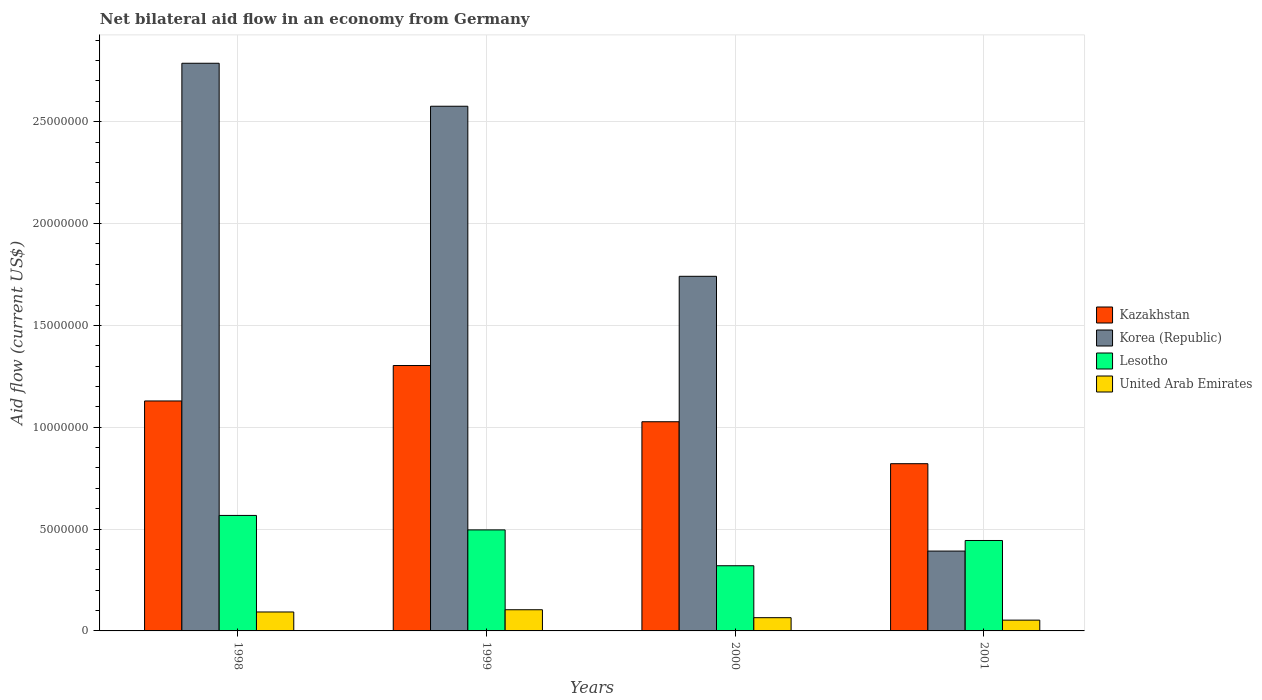How many different coloured bars are there?
Your response must be concise. 4. Are the number of bars per tick equal to the number of legend labels?
Offer a very short reply. Yes. How many bars are there on the 1st tick from the left?
Make the answer very short. 4. How many bars are there on the 1st tick from the right?
Give a very brief answer. 4. What is the label of the 3rd group of bars from the left?
Give a very brief answer. 2000. What is the net bilateral aid flow in Kazakhstan in 2000?
Offer a very short reply. 1.03e+07. Across all years, what is the maximum net bilateral aid flow in Kazakhstan?
Your response must be concise. 1.30e+07. Across all years, what is the minimum net bilateral aid flow in Lesotho?
Your answer should be compact. 3.20e+06. What is the total net bilateral aid flow in Kazakhstan in the graph?
Your response must be concise. 4.28e+07. What is the difference between the net bilateral aid flow in United Arab Emirates in 1998 and that in 1999?
Your answer should be compact. -1.10e+05. What is the difference between the net bilateral aid flow in United Arab Emirates in 1998 and the net bilateral aid flow in Korea (Republic) in 2001?
Give a very brief answer. -2.99e+06. What is the average net bilateral aid flow in United Arab Emirates per year?
Your answer should be compact. 7.88e+05. In the year 2000, what is the difference between the net bilateral aid flow in Lesotho and net bilateral aid flow in United Arab Emirates?
Make the answer very short. 2.55e+06. What is the ratio of the net bilateral aid flow in Korea (Republic) in 1998 to that in 2000?
Ensure brevity in your answer.  1.6. Is the net bilateral aid flow in United Arab Emirates in 2000 less than that in 2001?
Give a very brief answer. No. What is the difference between the highest and the second highest net bilateral aid flow in Lesotho?
Your response must be concise. 7.10e+05. What is the difference between the highest and the lowest net bilateral aid flow in Lesotho?
Offer a terse response. 2.47e+06. Is the sum of the net bilateral aid flow in United Arab Emirates in 1998 and 1999 greater than the maximum net bilateral aid flow in Lesotho across all years?
Provide a succinct answer. No. Is it the case that in every year, the sum of the net bilateral aid flow in Lesotho and net bilateral aid flow in Korea (Republic) is greater than the sum of net bilateral aid flow in Kazakhstan and net bilateral aid flow in United Arab Emirates?
Your response must be concise. Yes. What does the 4th bar from the left in 1999 represents?
Provide a short and direct response. United Arab Emirates. What does the 2nd bar from the right in 2001 represents?
Give a very brief answer. Lesotho. How many bars are there?
Your answer should be compact. 16. How many years are there in the graph?
Your answer should be compact. 4. Are the values on the major ticks of Y-axis written in scientific E-notation?
Offer a terse response. No. How many legend labels are there?
Make the answer very short. 4. How are the legend labels stacked?
Your answer should be very brief. Vertical. What is the title of the graph?
Keep it short and to the point. Net bilateral aid flow in an economy from Germany. Does "Mozambique" appear as one of the legend labels in the graph?
Keep it short and to the point. No. What is the label or title of the X-axis?
Make the answer very short. Years. What is the Aid flow (current US$) of Kazakhstan in 1998?
Offer a terse response. 1.13e+07. What is the Aid flow (current US$) of Korea (Republic) in 1998?
Ensure brevity in your answer.  2.79e+07. What is the Aid flow (current US$) of Lesotho in 1998?
Your answer should be compact. 5.67e+06. What is the Aid flow (current US$) in United Arab Emirates in 1998?
Offer a terse response. 9.30e+05. What is the Aid flow (current US$) in Kazakhstan in 1999?
Your answer should be very brief. 1.30e+07. What is the Aid flow (current US$) in Korea (Republic) in 1999?
Keep it short and to the point. 2.58e+07. What is the Aid flow (current US$) in Lesotho in 1999?
Give a very brief answer. 4.96e+06. What is the Aid flow (current US$) in United Arab Emirates in 1999?
Give a very brief answer. 1.04e+06. What is the Aid flow (current US$) in Kazakhstan in 2000?
Provide a short and direct response. 1.03e+07. What is the Aid flow (current US$) of Korea (Republic) in 2000?
Offer a very short reply. 1.74e+07. What is the Aid flow (current US$) in Lesotho in 2000?
Make the answer very short. 3.20e+06. What is the Aid flow (current US$) of United Arab Emirates in 2000?
Offer a terse response. 6.50e+05. What is the Aid flow (current US$) in Kazakhstan in 2001?
Make the answer very short. 8.21e+06. What is the Aid flow (current US$) in Korea (Republic) in 2001?
Offer a very short reply. 3.92e+06. What is the Aid flow (current US$) in Lesotho in 2001?
Offer a very short reply. 4.44e+06. What is the Aid flow (current US$) in United Arab Emirates in 2001?
Give a very brief answer. 5.30e+05. Across all years, what is the maximum Aid flow (current US$) of Kazakhstan?
Ensure brevity in your answer.  1.30e+07. Across all years, what is the maximum Aid flow (current US$) in Korea (Republic)?
Provide a succinct answer. 2.79e+07. Across all years, what is the maximum Aid flow (current US$) of Lesotho?
Give a very brief answer. 5.67e+06. Across all years, what is the maximum Aid flow (current US$) in United Arab Emirates?
Provide a short and direct response. 1.04e+06. Across all years, what is the minimum Aid flow (current US$) in Kazakhstan?
Your answer should be compact. 8.21e+06. Across all years, what is the minimum Aid flow (current US$) of Korea (Republic)?
Provide a short and direct response. 3.92e+06. Across all years, what is the minimum Aid flow (current US$) of Lesotho?
Make the answer very short. 3.20e+06. Across all years, what is the minimum Aid flow (current US$) of United Arab Emirates?
Ensure brevity in your answer.  5.30e+05. What is the total Aid flow (current US$) of Kazakhstan in the graph?
Your response must be concise. 4.28e+07. What is the total Aid flow (current US$) of Korea (Republic) in the graph?
Your answer should be very brief. 7.50e+07. What is the total Aid flow (current US$) in Lesotho in the graph?
Your answer should be very brief. 1.83e+07. What is the total Aid flow (current US$) of United Arab Emirates in the graph?
Give a very brief answer. 3.15e+06. What is the difference between the Aid flow (current US$) of Kazakhstan in 1998 and that in 1999?
Ensure brevity in your answer.  -1.74e+06. What is the difference between the Aid flow (current US$) in Korea (Republic) in 1998 and that in 1999?
Make the answer very short. 2.11e+06. What is the difference between the Aid flow (current US$) in Lesotho in 1998 and that in 1999?
Your response must be concise. 7.10e+05. What is the difference between the Aid flow (current US$) in United Arab Emirates in 1998 and that in 1999?
Offer a very short reply. -1.10e+05. What is the difference between the Aid flow (current US$) of Kazakhstan in 1998 and that in 2000?
Your answer should be very brief. 1.02e+06. What is the difference between the Aid flow (current US$) in Korea (Republic) in 1998 and that in 2000?
Give a very brief answer. 1.05e+07. What is the difference between the Aid flow (current US$) in Lesotho in 1998 and that in 2000?
Ensure brevity in your answer.  2.47e+06. What is the difference between the Aid flow (current US$) in United Arab Emirates in 1998 and that in 2000?
Your answer should be compact. 2.80e+05. What is the difference between the Aid flow (current US$) in Kazakhstan in 1998 and that in 2001?
Keep it short and to the point. 3.08e+06. What is the difference between the Aid flow (current US$) in Korea (Republic) in 1998 and that in 2001?
Give a very brief answer. 2.40e+07. What is the difference between the Aid flow (current US$) in Lesotho in 1998 and that in 2001?
Keep it short and to the point. 1.23e+06. What is the difference between the Aid flow (current US$) of United Arab Emirates in 1998 and that in 2001?
Give a very brief answer. 4.00e+05. What is the difference between the Aid flow (current US$) of Kazakhstan in 1999 and that in 2000?
Offer a very short reply. 2.76e+06. What is the difference between the Aid flow (current US$) in Korea (Republic) in 1999 and that in 2000?
Give a very brief answer. 8.35e+06. What is the difference between the Aid flow (current US$) of Lesotho in 1999 and that in 2000?
Make the answer very short. 1.76e+06. What is the difference between the Aid flow (current US$) in Kazakhstan in 1999 and that in 2001?
Provide a succinct answer. 4.82e+06. What is the difference between the Aid flow (current US$) in Korea (Republic) in 1999 and that in 2001?
Your answer should be very brief. 2.18e+07. What is the difference between the Aid flow (current US$) in Lesotho in 1999 and that in 2001?
Keep it short and to the point. 5.20e+05. What is the difference between the Aid flow (current US$) in United Arab Emirates in 1999 and that in 2001?
Keep it short and to the point. 5.10e+05. What is the difference between the Aid flow (current US$) in Kazakhstan in 2000 and that in 2001?
Keep it short and to the point. 2.06e+06. What is the difference between the Aid flow (current US$) in Korea (Republic) in 2000 and that in 2001?
Offer a very short reply. 1.35e+07. What is the difference between the Aid flow (current US$) in Lesotho in 2000 and that in 2001?
Keep it short and to the point. -1.24e+06. What is the difference between the Aid flow (current US$) of Kazakhstan in 1998 and the Aid flow (current US$) of Korea (Republic) in 1999?
Give a very brief answer. -1.45e+07. What is the difference between the Aid flow (current US$) in Kazakhstan in 1998 and the Aid flow (current US$) in Lesotho in 1999?
Provide a short and direct response. 6.33e+06. What is the difference between the Aid flow (current US$) in Kazakhstan in 1998 and the Aid flow (current US$) in United Arab Emirates in 1999?
Offer a very short reply. 1.02e+07. What is the difference between the Aid flow (current US$) in Korea (Republic) in 1998 and the Aid flow (current US$) in Lesotho in 1999?
Give a very brief answer. 2.29e+07. What is the difference between the Aid flow (current US$) in Korea (Republic) in 1998 and the Aid flow (current US$) in United Arab Emirates in 1999?
Offer a very short reply. 2.68e+07. What is the difference between the Aid flow (current US$) of Lesotho in 1998 and the Aid flow (current US$) of United Arab Emirates in 1999?
Ensure brevity in your answer.  4.63e+06. What is the difference between the Aid flow (current US$) in Kazakhstan in 1998 and the Aid flow (current US$) in Korea (Republic) in 2000?
Your answer should be very brief. -6.12e+06. What is the difference between the Aid flow (current US$) in Kazakhstan in 1998 and the Aid flow (current US$) in Lesotho in 2000?
Provide a succinct answer. 8.09e+06. What is the difference between the Aid flow (current US$) of Kazakhstan in 1998 and the Aid flow (current US$) of United Arab Emirates in 2000?
Your answer should be compact. 1.06e+07. What is the difference between the Aid flow (current US$) of Korea (Republic) in 1998 and the Aid flow (current US$) of Lesotho in 2000?
Keep it short and to the point. 2.47e+07. What is the difference between the Aid flow (current US$) in Korea (Republic) in 1998 and the Aid flow (current US$) in United Arab Emirates in 2000?
Ensure brevity in your answer.  2.72e+07. What is the difference between the Aid flow (current US$) of Lesotho in 1998 and the Aid flow (current US$) of United Arab Emirates in 2000?
Offer a very short reply. 5.02e+06. What is the difference between the Aid flow (current US$) of Kazakhstan in 1998 and the Aid flow (current US$) of Korea (Republic) in 2001?
Offer a terse response. 7.37e+06. What is the difference between the Aid flow (current US$) of Kazakhstan in 1998 and the Aid flow (current US$) of Lesotho in 2001?
Your answer should be compact. 6.85e+06. What is the difference between the Aid flow (current US$) of Kazakhstan in 1998 and the Aid flow (current US$) of United Arab Emirates in 2001?
Your answer should be very brief. 1.08e+07. What is the difference between the Aid flow (current US$) in Korea (Republic) in 1998 and the Aid flow (current US$) in Lesotho in 2001?
Ensure brevity in your answer.  2.34e+07. What is the difference between the Aid flow (current US$) in Korea (Republic) in 1998 and the Aid flow (current US$) in United Arab Emirates in 2001?
Offer a very short reply. 2.73e+07. What is the difference between the Aid flow (current US$) in Lesotho in 1998 and the Aid flow (current US$) in United Arab Emirates in 2001?
Offer a very short reply. 5.14e+06. What is the difference between the Aid flow (current US$) of Kazakhstan in 1999 and the Aid flow (current US$) of Korea (Republic) in 2000?
Keep it short and to the point. -4.38e+06. What is the difference between the Aid flow (current US$) of Kazakhstan in 1999 and the Aid flow (current US$) of Lesotho in 2000?
Offer a very short reply. 9.83e+06. What is the difference between the Aid flow (current US$) of Kazakhstan in 1999 and the Aid flow (current US$) of United Arab Emirates in 2000?
Your response must be concise. 1.24e+07. What is the difference between the Aid flow (current US$) of Korea (Republic) in 1999 and the Aid flow (current US$) of Lesotho in 2000?
Give a very brief answer. 2.26e+07. What is the difference between the Aid flow (current US$) in Korea (Republic) in 1999 and the Aid flow (current US$) in United Arab Emirates in 2000?
Provide a short and direct response. 2.51e+07. What is the difference between the Aid flow (current US$) of Lesotho in 1999 and the Aid flow (current US$) of United Arab Emirates in 2000?
Offer a terse response. 4.31e+06. What is the difference between the Aid flow (current US$) in Kazakhstan in 1999 and the Aid flow (current US$) in Korea (Republic) in 2001?
Make the answer very short. 9.11e+06. What is the difference between the Aid flow (current US$) in Kazakhstan in 1999 and the Aid flow (current US$) in Lesotho in 2001?
Your answer should be compact. 8.59e+06. What is the difference between the Aid flow (current US$) in Kazakhstan in 1999 and the Aid flow (current US$) in United Arab Emirates in 2001?
Offer a terse response. 1.25e+07. What is the difference between the Aid flow (current US$) of Korea (Republic) in 1999 and the Aid flow (current US$) of Lesotho in 2001?
Your answer should be compact. 2.13e+07. What is the difference between the Aid flow (current US$) in Korea (Republic) in 1999 and the Aid flow (current US$) in United Arab Emirates in 2001?
Offer a terse response. 2.52e+07. What is the difference between the Aid flow (current US$) in Lesotho in 1999 and the Aid flow (current US$) in United Arab Emirates in 2001?
Give a very brief answer. 4.43e+06. What is the difference between the Aid flow (current US$) in Kazakhstan in 2000 and the Aid flow (current US$) in Korea (Republic) in 2001?
Offer a terse response. 6.35e+06. What is the difference between the Aid flow (current US$) in Kazakhstan in 2000 and the Aid flow (current US$) in Lesotho in 2001?
Make the answer very short. 5.83e+06. What is the difference between the Aid flow (current US$) in Kazakhstan in 2000 and the Aid flow (current US$) in United Arab Emirates in 2001?
Ensure brevity in your answer.  9.74e+06. What is the difference between the Aid flow (current US$) in Korea (Republic) in 2000 and the Aid flow (current US$) in Lesotho in 2001?
Provide a short and direct response. 1.30e+07. What is the difference between the Aid flow (current US$) of Korea (Republic) in 2000 and the Aid flow (current US$) of United Arab Emirates in 2001?
Provide a succinct answer. 1.69e+07. What is the difference between the Aid flow (current US$) of Lesotho in 2000 and the Aid flow (current US$) of United Arab Emirates in 2001?
Make the answer very short. 2.67e+06. What is the average Aid flow (current US$) in Kazakhstan per year?
Give a very brief answer. 1.07e+07. What is the average Aid flow (current US$) of Korea (Republic) per year?
Make the answer very short. 1.87e+07. What is the average Aid flow (current US$) in Lesotho per year?
Offer a very short reply. 4.57e+06. What is the average Aid flow (current US$) of United Arab Emirates per year?
Your response must be concise. 7.88e+05. In the year 1998, what is the difference between the Aid flow (current US$) of Kazakhstan and Aid flow (current US$) of Korea (Republic)?
Your answer should be compact. -1.66e+07. In the year 1998, what is the difference between the Aid flow (current US$) in Kazakhstan and Aid flow (current US$) in Lesotho?
Give a very brief answer. 5.62e+06. In the year 1998, what is the difference between the Aid flow (current US$) of Kazakhstan and Aid flow (current US$) of United Arab Emirates?
Your answer should be very brief. 1.04e+07. In the year 1998, what is the difference between the Aid flow (current US$) in Korea (Republic) and Aid flow (current US$) in Lesotho?
Your response must be concise. 2.22e+07. In the year 1998, what is the difference between the Aid flow (current US$) of Korea (Republic) and Aid flow (current US$) of United Arab Emirates?
Ensure brevity in your answer.  2.69e+07. In the year 1998, what is the difference between the Aid flow (current US$) of Lesotho and Aid flow (current US$) of United Arab Emirates?
Provide a short and direct response. 4.74e+06. In the year 1999, what is the difference between the Aid flow (current US$) in Kazakhstan and Aid flow (current US$) in Korea (Republic)?
Your answer should be compact. -1.27e+07. In the year 1999, what is the difference between the Aid flow (current US$) in Kazakhstan and Aid flow (current US$) in Lesotho?
Offer a terse response. 8.07e+06. In the year 1999, what is the difference between the Aid flow (current US$) of Kazakhstan and Aid flow (current US$) of United Arab Emirates?
Ensure brevity in your answer.  1.20e+07. In the year 1999, what is the difference between the Aid flow (current US$) in Korea (Republic) and Aid flow (current US$) in Lesotho?
Keep it short and to the point. 2.08e+07. In the year 1999, what is the difference between the Aid flow (current US$) of Korea (Republic) and Aid flow (current US$) of United Arab Emirates?
Offer a very short reply. 2.47e+07. In the year 1999, what is the difference between the Aid flow (current US$) of Lesotho and Aid flow (current US$) of United Arab Emirates?
Give a very brief answer. 3.92e+06. In the year 2000, what is the difference between the Aid flow (current US$) of Kazakhstan and Aid flow (current US$) of Korea (Republic)?
Your response must be concise. -7.14e+06. In the year 2000, what is the difference between the Aid flow (current US$) of Kazakhstan and Aid flow (current US$) of Lesotho?
Keep it short and to the point. 7.07e+06. In the year 2000, what is the difference between the Aid flow (current US$) in Kazakhstan and Aid flow (current US$) in United Arab Emirates?
Give a very brief answer. 9.62e+06. In the year 2000, what is the difference between the Aid flow (current US$) of Korea (Republic) and Aid flow (current US$) of Lesotho?
Provide a succinct answer. 1.42e+07. In the year 2000, what is the difference between the Aid flow (current US$) in Korea (Republic) and Aid flow (current US$) in United Arab Emirates?
Offer a very short reply. 1.68e+07. In the year 2000, what is the difference between the Aid flow (current US$) in Lesotho and Aid flow (current US$) in United Arab Emirates?
Provide a short and direct response. 2.55e+06. In the year 2001, what is the difference between the Aid flow (current US$) in Kazakhstan and Aid flow (current US$) in Korea (Republic)?
Ensure brevity in your answer.  4.29e+06. In the year 2001, what is the difference between the Aid flow (current US$) of Kazakhstan and Aid flow (current US$) of Lesotho?
Provide a succinct answer. 3.77e+06. In the year 2001, what is the difference between the Aid flow (current US$) of Kazakhstan and Aid flow (current US$) of United Arab Emirates?
Provide a short and direct response. 7.68e+06. In the year 2001, what is the difference between the Aid flow (current US$) of Korea (Republic) and Aid flow (current US$) of Lesotho?
Your response must be concise. -5.20e+05. In the year 2001, what is the difference between the Aid flow (current US$) of Korea (Republic) and Aid flow (current US$) of United Arab Emirates?
Your answer should be compact. 3.39e+06. In the year 2001, what is the difference between the Aid flow (current US$) of Lesotho and Aid flow (current US$) of United Arab Emirates?
Keep it short and to the point. 3.91e+06. What is the ratio of the Aid flow (current US$) in Kazakhstan in 1998 to that in 1999?
Your response must be concise. 0.87. What is the ratio of the Aid flow (current US$) of Korea (Republic) in 1998 to that in 1999?
Your answer should be very brief. 1.08. What is the ratio of the Aid flow (current US$) of Lesotho in 1998 to that in 1999?
Provide a succinct answer. 1.14. What is the ratio of the Aid flow (current US$) in United Arab Emirates in 1998 to that in 1999?
Offer a terse response. 0.89. What is the ratio of the Aid flow (current US$) in Kazakhstan in 1998 to that in 2000?
Offer a terse response. 1.1. What is the ratio of the Aid flow (current US$) in Korea (Republic) in 1998 to that in 2000?
Offer a terse response. 1.6. What is the ratio of the Aid flow (current US$) in Lesotho in 1998 to that in 2000?
Make the answer very short. 1.77. What is the ratio of the Aid flow (current US$) in United Arab Emirates in 1998 to that in 2000?
Provide a succinct answer. 1.43. What is the ratio of the Aid flow (current US$) in Kazakhstan in 1998 to that in 2001?
Ensure brevity in your answer.  1.38. What is the ratio of the Aid flow (current US$) in Korea (Republic) in 1998 to that in 2001?
Keep it short and to the point. 7.11. What is the ratio of the Aid flow (current US$) of Lesotho in 1998 to that in 2001?
Provide a short and direct response. 1.28. What is the ratio of the Aid flow (current US$) in United Arab Emirates in 1998 to that in 2001?
Offer a very short reply. 1.75. What is the ratio of the Aid flow (current US$) in Kazakhstan in 1999 to that in 2000?
Your response must be concise. 1.27. What is the ratio of the Aid flow (current US$) of Korea (Republic) in 1999 to that in 2000?
Your answer should be very brief. 1.48. What is the ratio of the Aid flow (current US$) in Lesotho in 1999 to that in 2000?
Your response must be concise. 1.55. What is the ratio of the Aid flow (current US$) of Kazakhstan in 1999 to that in 2001?
Your answer should be compact. 1.59. What is the ratio of the Aid flow (current US$) in Korea (Republic) in 1999 to that in 2001?
Make the answer very short. 6.57. What is the ratio of the Aid flow (current US$) in Lesotho in 1999 to that in 2001?
Offer a very short reply. 1.12. What is the ratio of the Aid flow (current US$) in United Arab Emirates in 1999 to that in 2001?
Provide a succinct answer. 1.96. What is the ratio of the Aid flow (current US$) in Kazakhstan in 2000 to that in 2001?
Your answer should be very brief. 1.25. What is the ratio of the Aid flow (current US$) of Korea (Republic) in 2000 to that in 2001?
Give a very brief answer. 4.44. What is the ratio of the Aid flow (current US$) of Lesotho in 2000 to that in 2001?
Provide a short and direct response. 0.72. What is the ratio of the Aid flow (current US$) in United Arab Emirates in 2000 to that in 2001?
Your response must be concise. 1.23. What is the difference between the highest and the second highest Aid flow (current US$) in Kazakhstan?
Provide a succinct answer. 1.74e+06. What is the difference between the highest and the second highest Aid flow (current US$) of Korea (Republic)?
Make the answer very short. 2.11e+06. What is the difference between the highest and the second highest Aid flow (current US$) in Lesotho?
Your response must be concise. 7.10e+05. What is the difference between the highest and the lowest Aid flow (current US$) of Kazakhstan?
Your answer should be compact. 4.82e+06. What is the difference between the highest and the lowest Aid flow (current US$) in Korea (Republic)?
Your answer should be compact. 2.40e+07. What is the difference between the highest and the lowest Aid flow (current US$) of Lesotho?
Your answer should be compact. 2.47e+06. What is the difference between the highest and the lowest Aid flow (current US$) of United Arab Emirates?
Ensure brevity in your answer.  5.10e+05. 